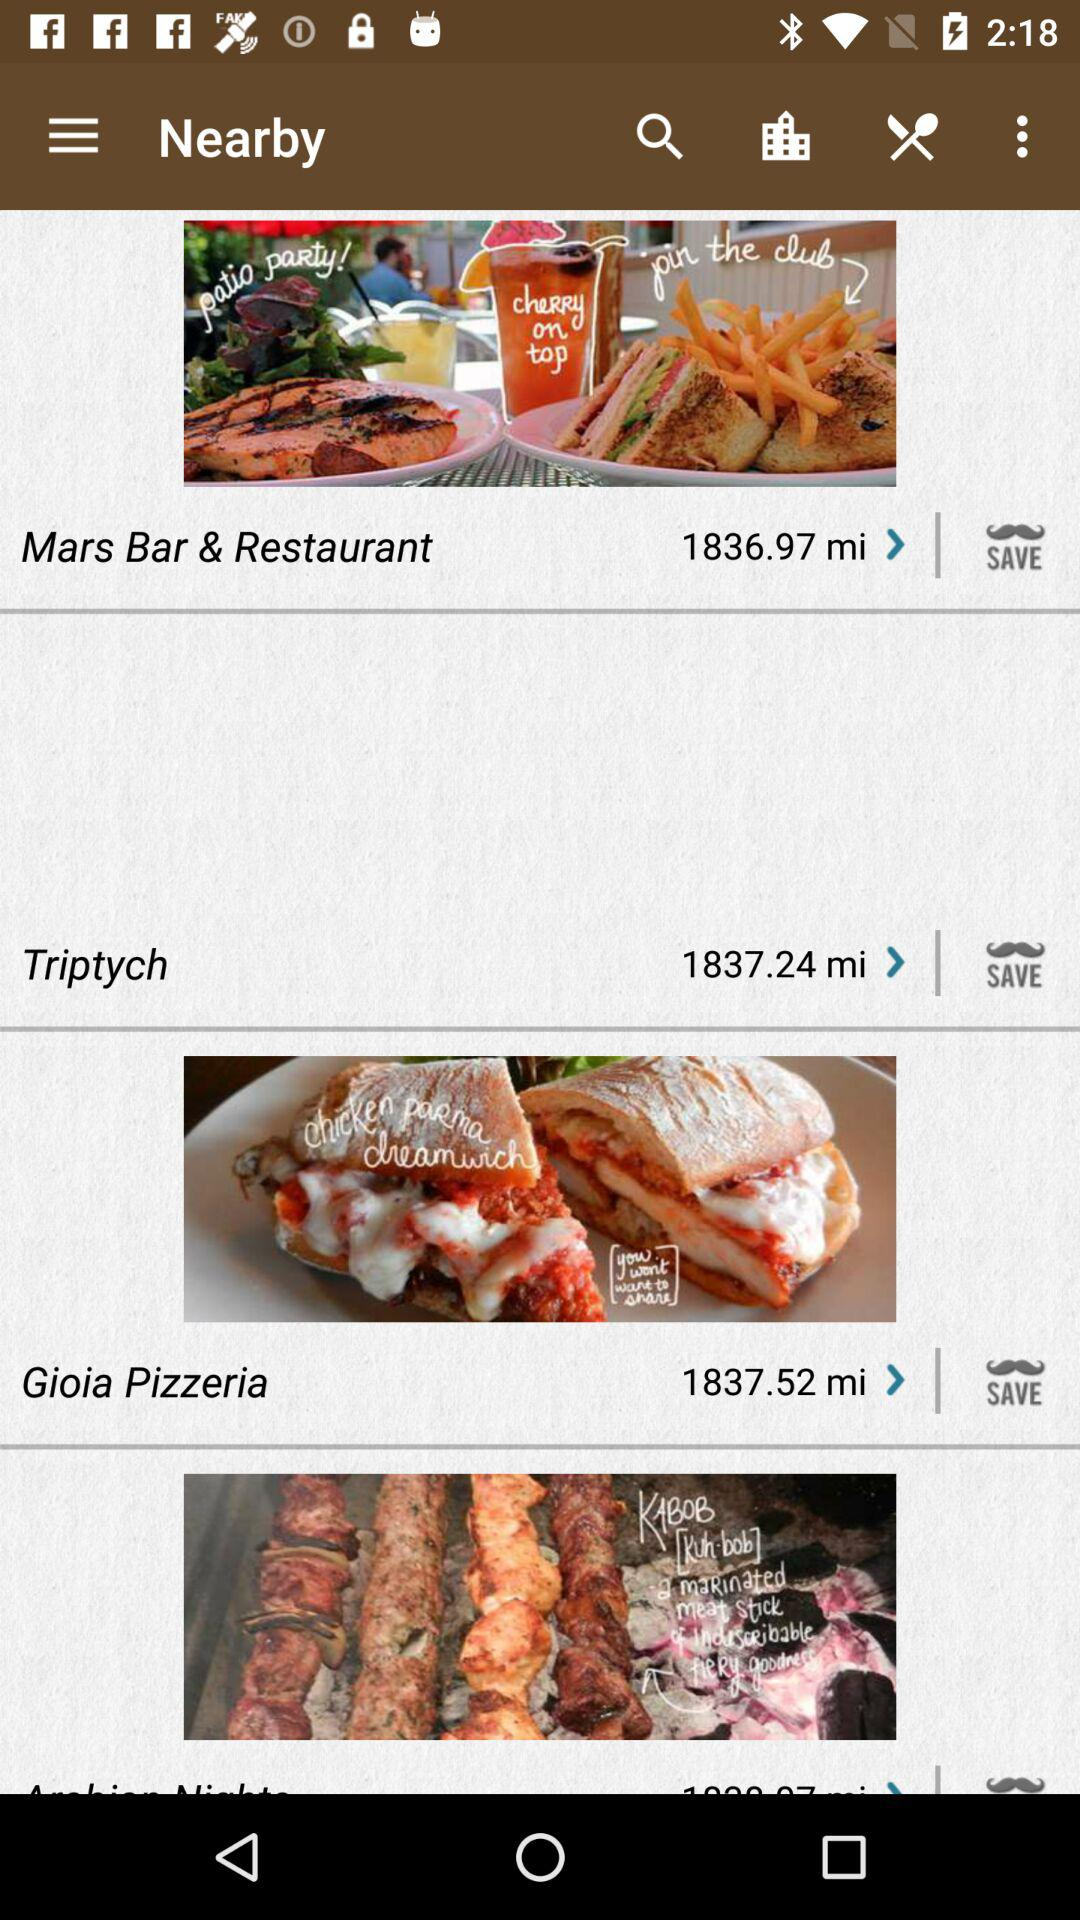At what distance is Triptych located from my location? Triptych is located 1837.24 miles away from my location. 